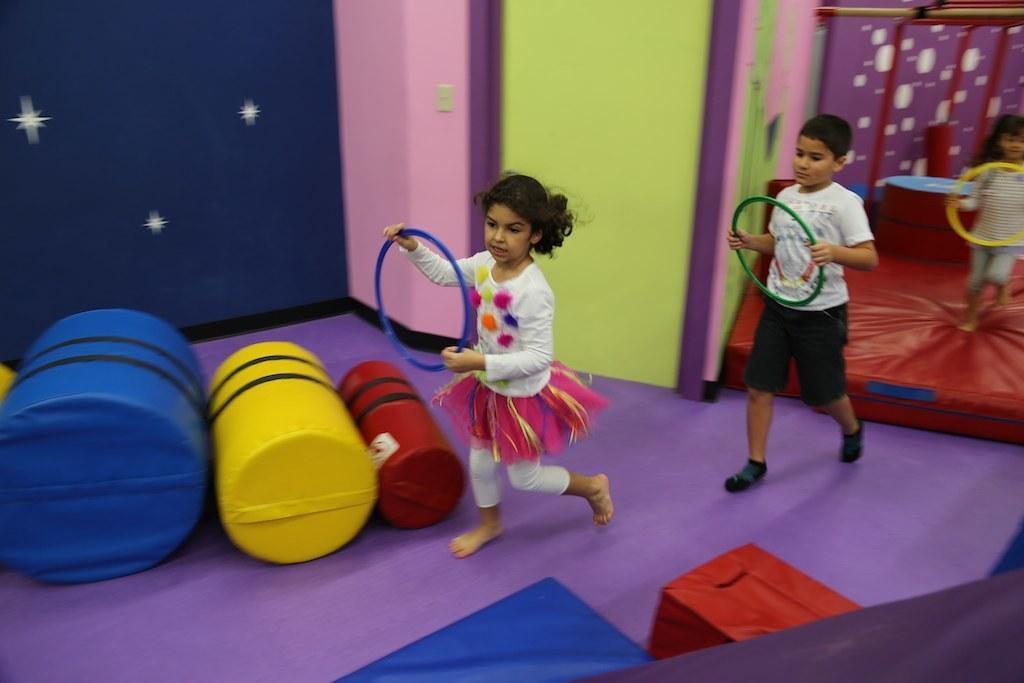Could you give a brief overview of what you see in this image? In this image I can see three people with different color dresses. These people are holding the blue, green and yellow color rings. To the left I can see the some colorful objects. In the background I can also see the colorful wall. 